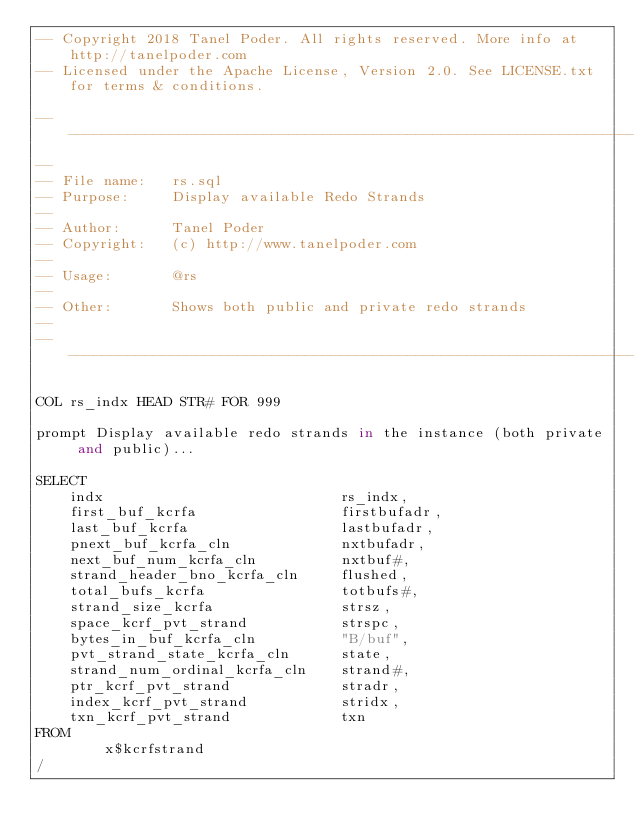Convert code to text. <code><loc_0><loc_0><loc_500><loc_500><_SQL_>-- Copyright 2018 Tanel Poder. All rights reserved. More info at http://tanelpoder.com
-- Licensed under the Apache License, Version 2.0. See LICENSE.txt for terms & conditions.

--------------------------------------------------------------------------------
--
-- File name:   rs.sql
-- Purpose:     Display available Redo Strands
--
-- Author:      Tanel Poder
-- Copyright:   (c) http://www.tanelpoder.com
--              
-- Usage:       @rs
--          
-- Other:       Shows both public and private redo strands
--
--------------------------------------------------------------------------------

COL rs_indx HEAD STR# FOR 999

prompt Display available redo strands in the instance (both private and public)...

SELECT 
    indx                            rs_indx,
    first_buf_kcrfa                 firstbufadr,
    last_buf_kcrfa                  lastbufadr,
    pnext_buf_kcrfa_cln             nxtbufadr, 
    next_buf_num_kcrfa_cln          nxtbuf#, 
    strand_header_bno_kcrfa_cln     flushed,
    total_bufs_kcrfa                totbufs#, 
    strand_size_kcrfa               strsz,
    space_kcrf_pvt_strand           strspc,
    bytes_in_buf_kcrfa_cln          "B/buf", 
    pvt_strand_state_kcrfa_cln      state,
    strand_num_ordinal_kcrfa_cln    strand#, 
    ptr_kcrf_pvt_strand             stradr, 
    index_kcrf_pvt_strand           stridx, 
    txn_kcrf_pvt_strand             txn
FROM 
        x$kcrfstrand
/


</code> 